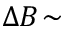<formula> <loc_0><loc_0><loc_500><loc_500>\Delta B \, \sim</formula> 